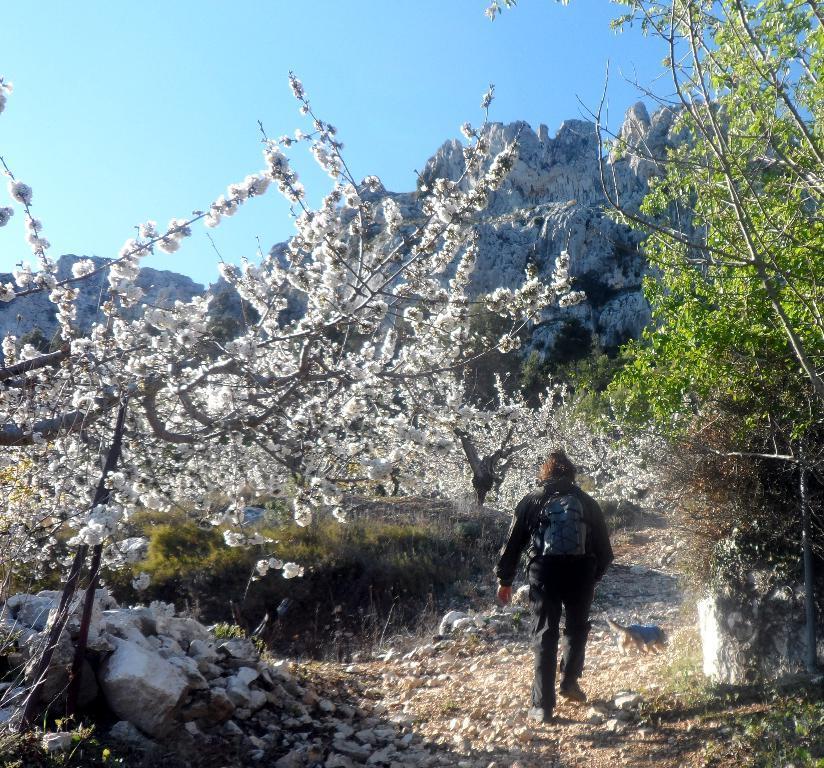How would you summarize this image in a sentence or two? In the foreground I can see a person and an animal on the road. In the background I can see flowering plants, trees, mountains and the sky. This image is taken may be during a day. 